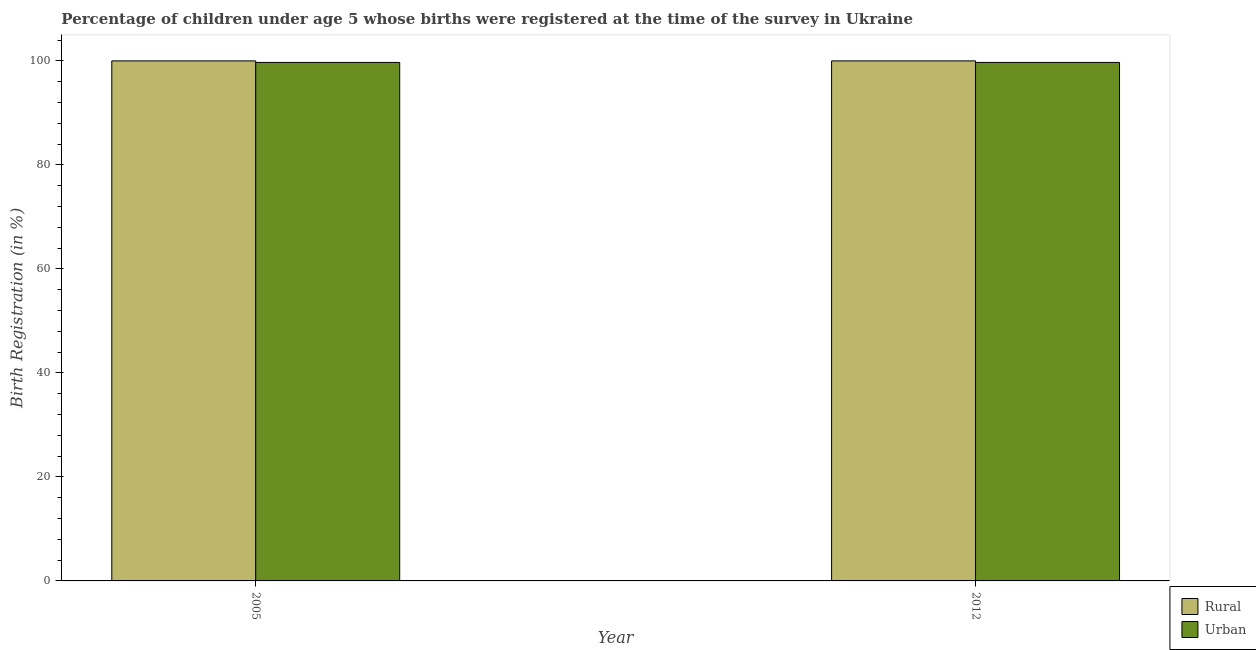How many groups of bars are there?
Provide a short and direct response. 2. How many bars are there on the 2nd tick from the left?
Provide a succinct answer. 2. What is the label of the 2nd group of bars from the left?
Keep it short and to the point. 2012. In how many cases, is the number of bars for a given year not equal to the number of legend labels?
Provide a succinct answer. 0. What is the rural birth registration in 2005?
Your answer should be compact. 100. Across all years, what is the maximum urban birth registration?
Offer a very short reply. 99.7. Across all years, what is the minimum urban birth registration?
Provide a succinct answer. 99.7. In which year was the urban birth registration maximum?
Offer a terse response. 2005. What is the total urban birth registration in the graph?
Make the answer very short. 199.4. What is the difference between the urban birth registration in 2012 and the rural birth registration in 2005?
Ensure brevity in your answer.  0. What is the average urban birth registration per year?
Your answer should be very brief. 99.7. What is the ratio of the urban birth registration in 2005 to that in 2012?
Give a very brief answer. 1. What does the 1st bar from the left in 2012 represents?
Make the answer very short. Rural. What does the 2nd bar from the right in 2012 represents?
Your answer should be very brief. Rural. How many bars are there?
Your response must be concise. 4. How many years are there in the graph?
Keep it short and to the point. 2. Are the values on the major ticks of Y-axis written in scientific E-notation?
Your answer should be compact. No. Does the graph contain any zero values?
Your answer should be compact. No. How are the legend labels stacked?
Give a very brief answer. Vertical. What is the title of the graph?
Offer a very short reply. Percentage of children under age 5 whose births were registered at the time of the survey in Ukraine. What is the label or title of the Y-axis?
Your answer should be very brief. Birth Registration (in %). What is the Birth Registration (in %) in Rural in 2005?
Keep it short and to the point. 100. What is the Birth Registration (in %) in Urban in 2005?
Offer a terse response. 99.7. What is the Birth Registration (in %) of Urban in 2012?
Offer a very short reply. 99.7. Across all years, what is the maximum Birth Registration (in %) in Urban?
Give a very brief answer. 99.7. Across all years, what is the minimum Birth Registration (in %) of Urban?
Your response must be concise. 99.7. What is the total Birth Registration (in %) in Urban in the graph?
Make the answer very short. 199.4. What is the difference between the Birth Registration (in %) of Rural in 2005 and that in 2012?
Your answer should be very brief. 0. What is the average Birth Registration (in %) of Urban per year?
Provide a succinct answer. 99.7. What is the difference between the highest and the second highest Birth Registration (in %) of Urban?
Your answer should be compact. 0. What is the difference between the highest and the lowest Birth Registration (in %) in Rural?
Provide a succinct answer. 0. What is the difference between the highest and the lowest Birth Registration (in %) of Urban?
Offer a terse response. 0. 